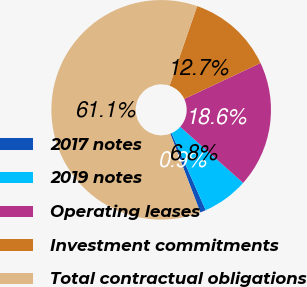Convert chart. <chart><loc_0><loc_0><loc_500><loc_500><pie_chart><fcel>2017 notes<fcel>2019 notes<fcel>Operating leases<fcel>Investment commitments<fcel>Total contractual obligations<nl><fcel>0.85%<fcel>6.76%<fcel>18.6%<fcel>12.68%<fcel>61.11%<nl></chart> 